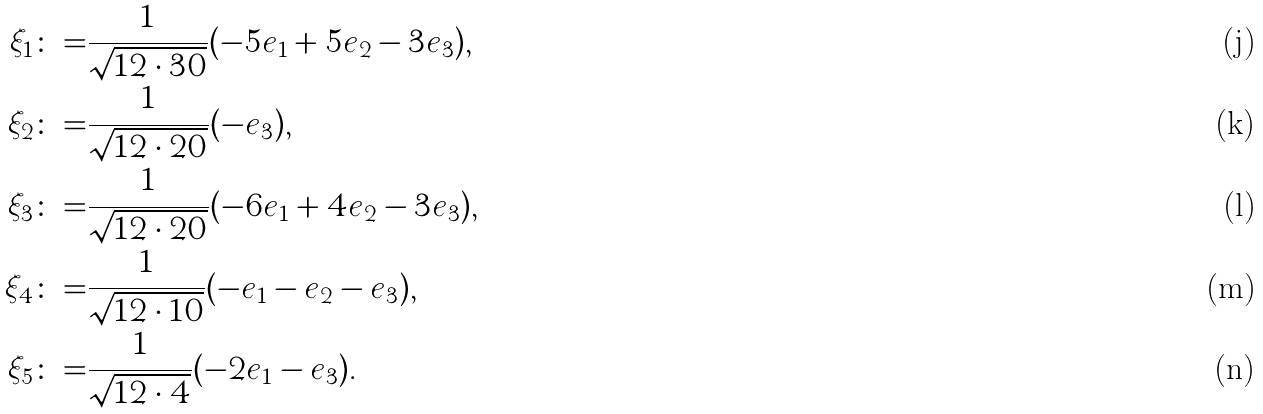<formula> <loc_0><loc_0><loc_500><loc_500>\xi _ { 1 } \colon = & \frac { 1 } { \sqrt { 1 2 \cdot 3 0 } } ( - 5 e _ { 1 } + 5 e _ { 2 } - 3 e _ { 3 } ) , \\ \xi _ { 2 } \colon = & \frac { 1 } { \sqrt { 1 2 \cdot 2 0 } } ( - e _ { 3 } ) , \\ \xi _ { 3 } \colon = & \frac { 1 } { \sqrt { 1 2 \cdot 2 0 } } ( - 6 e _ { 1 } + 4 e _ { 2 } - 3 e _ { 3 } ) , \\ \xi _ { 4 } \colon = & \frac { 1 } { \sqrt { 1 2 \cdot 1 0 } } ( - e _ { 1 } - e _ { 2 } - e _ { 3 } ) , \\ \xi _ { 5 } \colon = & \frac { 1 } { \sqrt { 1 2 \cdot 4 } } ( - 2 e _ { 1 } - e _ { 3 } ) .</formula> 